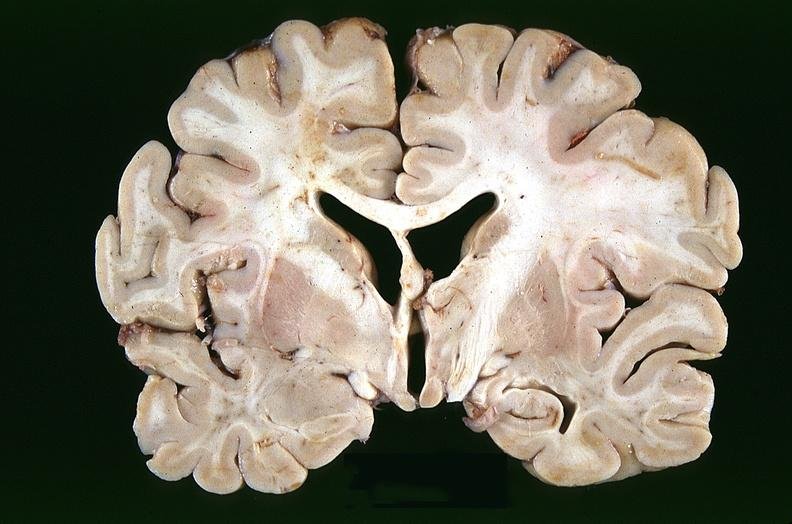what is present?
Answer the question using a single word or phrase. Nervous 